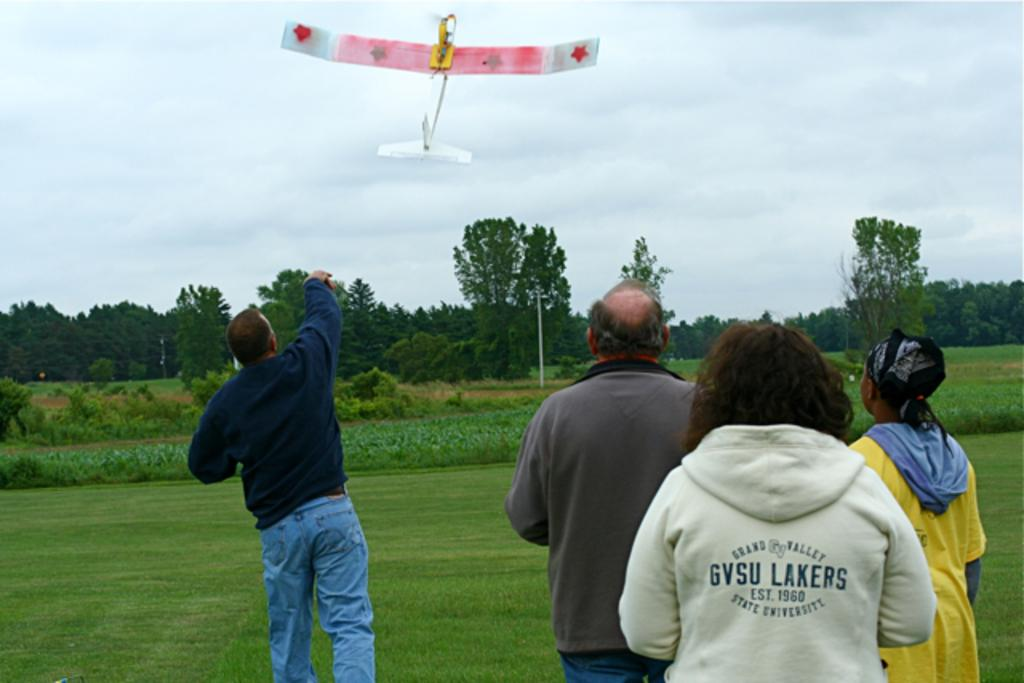<image>
Create a compact narrative representing the image presented. Great Valley jacket with the JV logo from GVSU Lakers. 